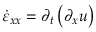Convert formula to latex. <formula><loc_0><loc_0><loc_500><loc_500>\dot { \varepsilon } _ { x x } = \partial _ { t } \left ( \partial _ { x } u \right )</formula> 